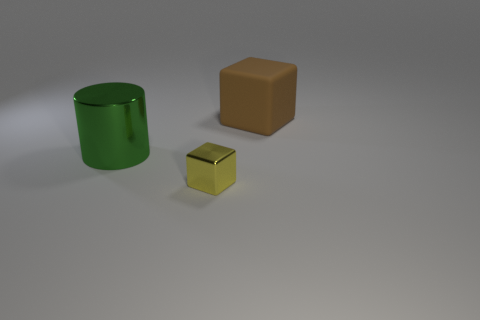Add 1 purple matte blocks. How many objects exist? 4 Subtract all cubes. How many objects are left? 1 Add 1 large matte objects. How many large matte objects are left? 2 Add 2 blue matte objects. How many blue matte objects exist? 2 Subtract 0 cyan cylinders. How many objects are left? 3 Subtract 1 cylinders. How many cylinders are left? 0 Subtract all gray cylinders. Subtract all gray cubes. How many cylinders are left? 1 Subtract all small blue objects. Subtract all rubber blocks. How many objects are left? 2 